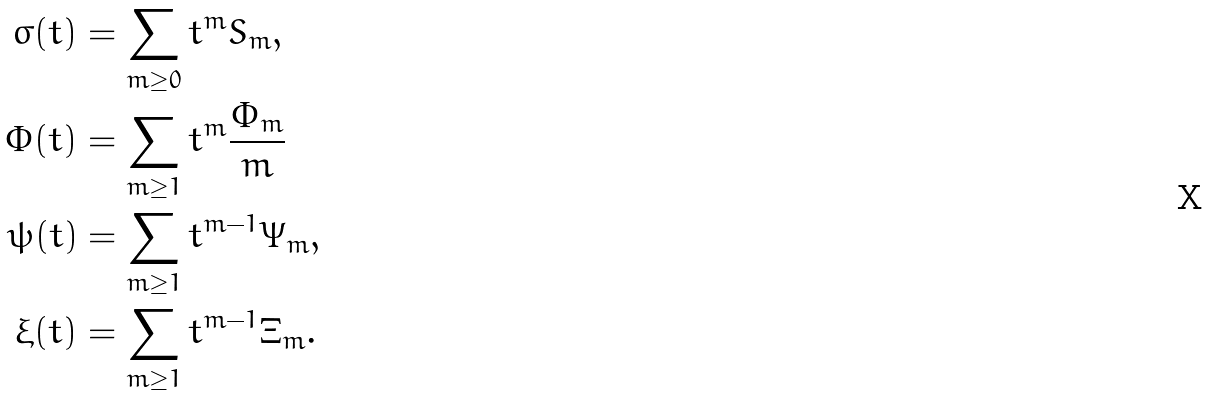<formula> <loc_0><loc_0><loc_500><loc_500>\sigma ( t ) & = \sum _ { m \geq 0 } t ^ { m } S _ { m } , \\ \Phi ( t ) & = \sum _ { m \geq 1 } t ^ { m } \frac { \Phi _ { m } } m \\ \psi ( t ) & = \sum _ { m \geq 1 } t ^ { m - 1 } \Psi _ { m } , \\ \xi ( t ) & = \sum _ { m \geq 1 } t ^ { m - 1 } \Xi _ { m } .</formula> 